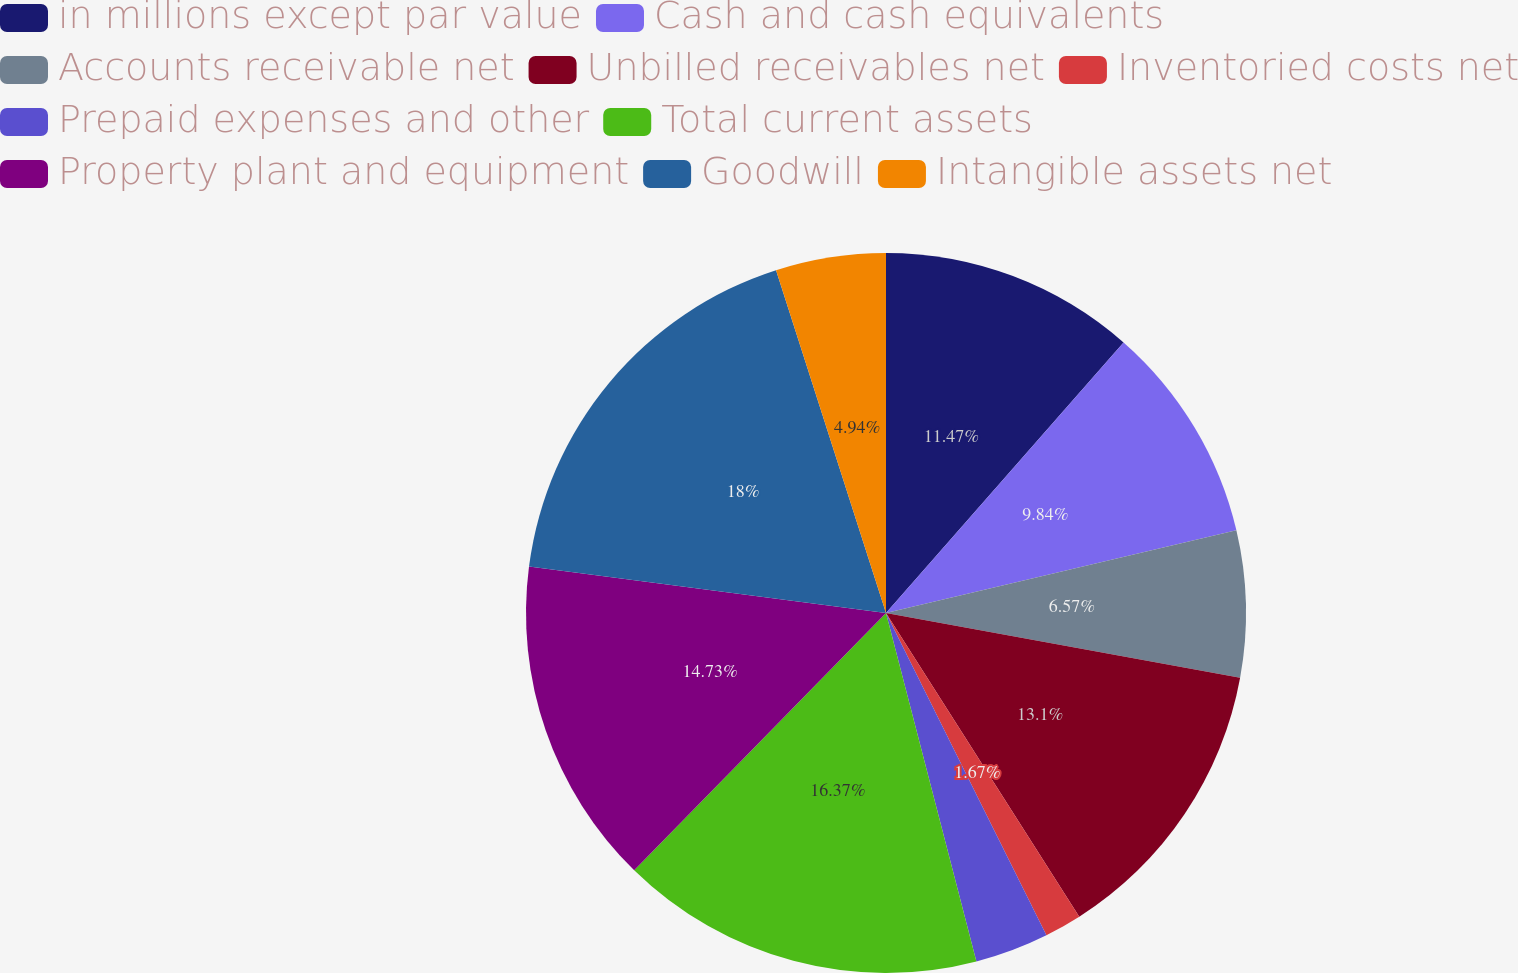Convert chart to OTSL. <chart><loc_0><loc_0><loc_500><loc_500><pie_chart><fcel>in millions except par value<fcel>Cash and cash equivalents<fcel>Accounts receivable net<fcel>Unbilled receivables net<fcel>Inventoried costs net<fcel>Prepaid expenses and other<fcel>Total current assets<fcel>Property plant and equipment<fcel>Goodwill<fcel>Intangible assets net<nl><fcel>11.47%<fcel>9.84%<fcel>6.57%<fcel>13.1%<fcel>1.67%<fcel>3.31%<fcel>16.37%<fcel>14.73%<fcel>18.0%<fcel>4.94%<nl></chart> 